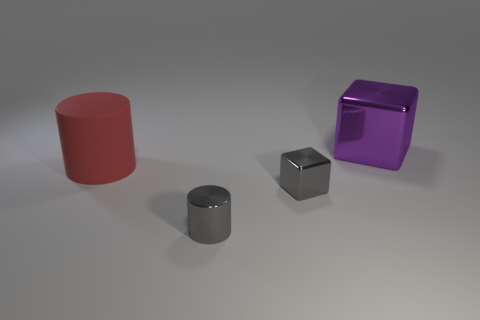Add 2 big cyan matte cylinders. How many objects exist? 6 Subtract 0 cyan cubes. How many objects are left? 4 Subtract all red things. Subtract all large purple metallic things. How many objects are left? 2 Add 1 purple metallic blocks. How many purple metallic blocks are left? 2 Add 3 tiny gray metal cylinders. How many tiny gray metal cylinders exist? 4 